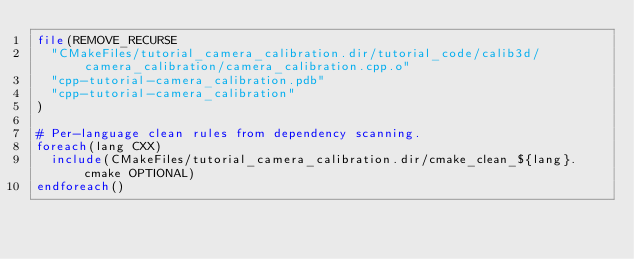<code> <loc_0><loc_0><loc_500><loc_500><_CMake_>file(REMOVE_RECURSE
  "CMakeFiles/tutorial_camera_calibration.dir/tutorial_code/calib3d/camera_calibration/camera_calibration.cpp.o"
  "cpp-tutorial-camera_calibration.pdb"
  "cpp-tutorial-camera_calibration"
)

# Per-language clean rules from dependency scanning.
foreach(lang CXX)
  include(CMakeFiles/tutorial_camera_calibration.dir/cmake_clean_${lang}.cmake OPTIONAL)
endforeach()
</code> 